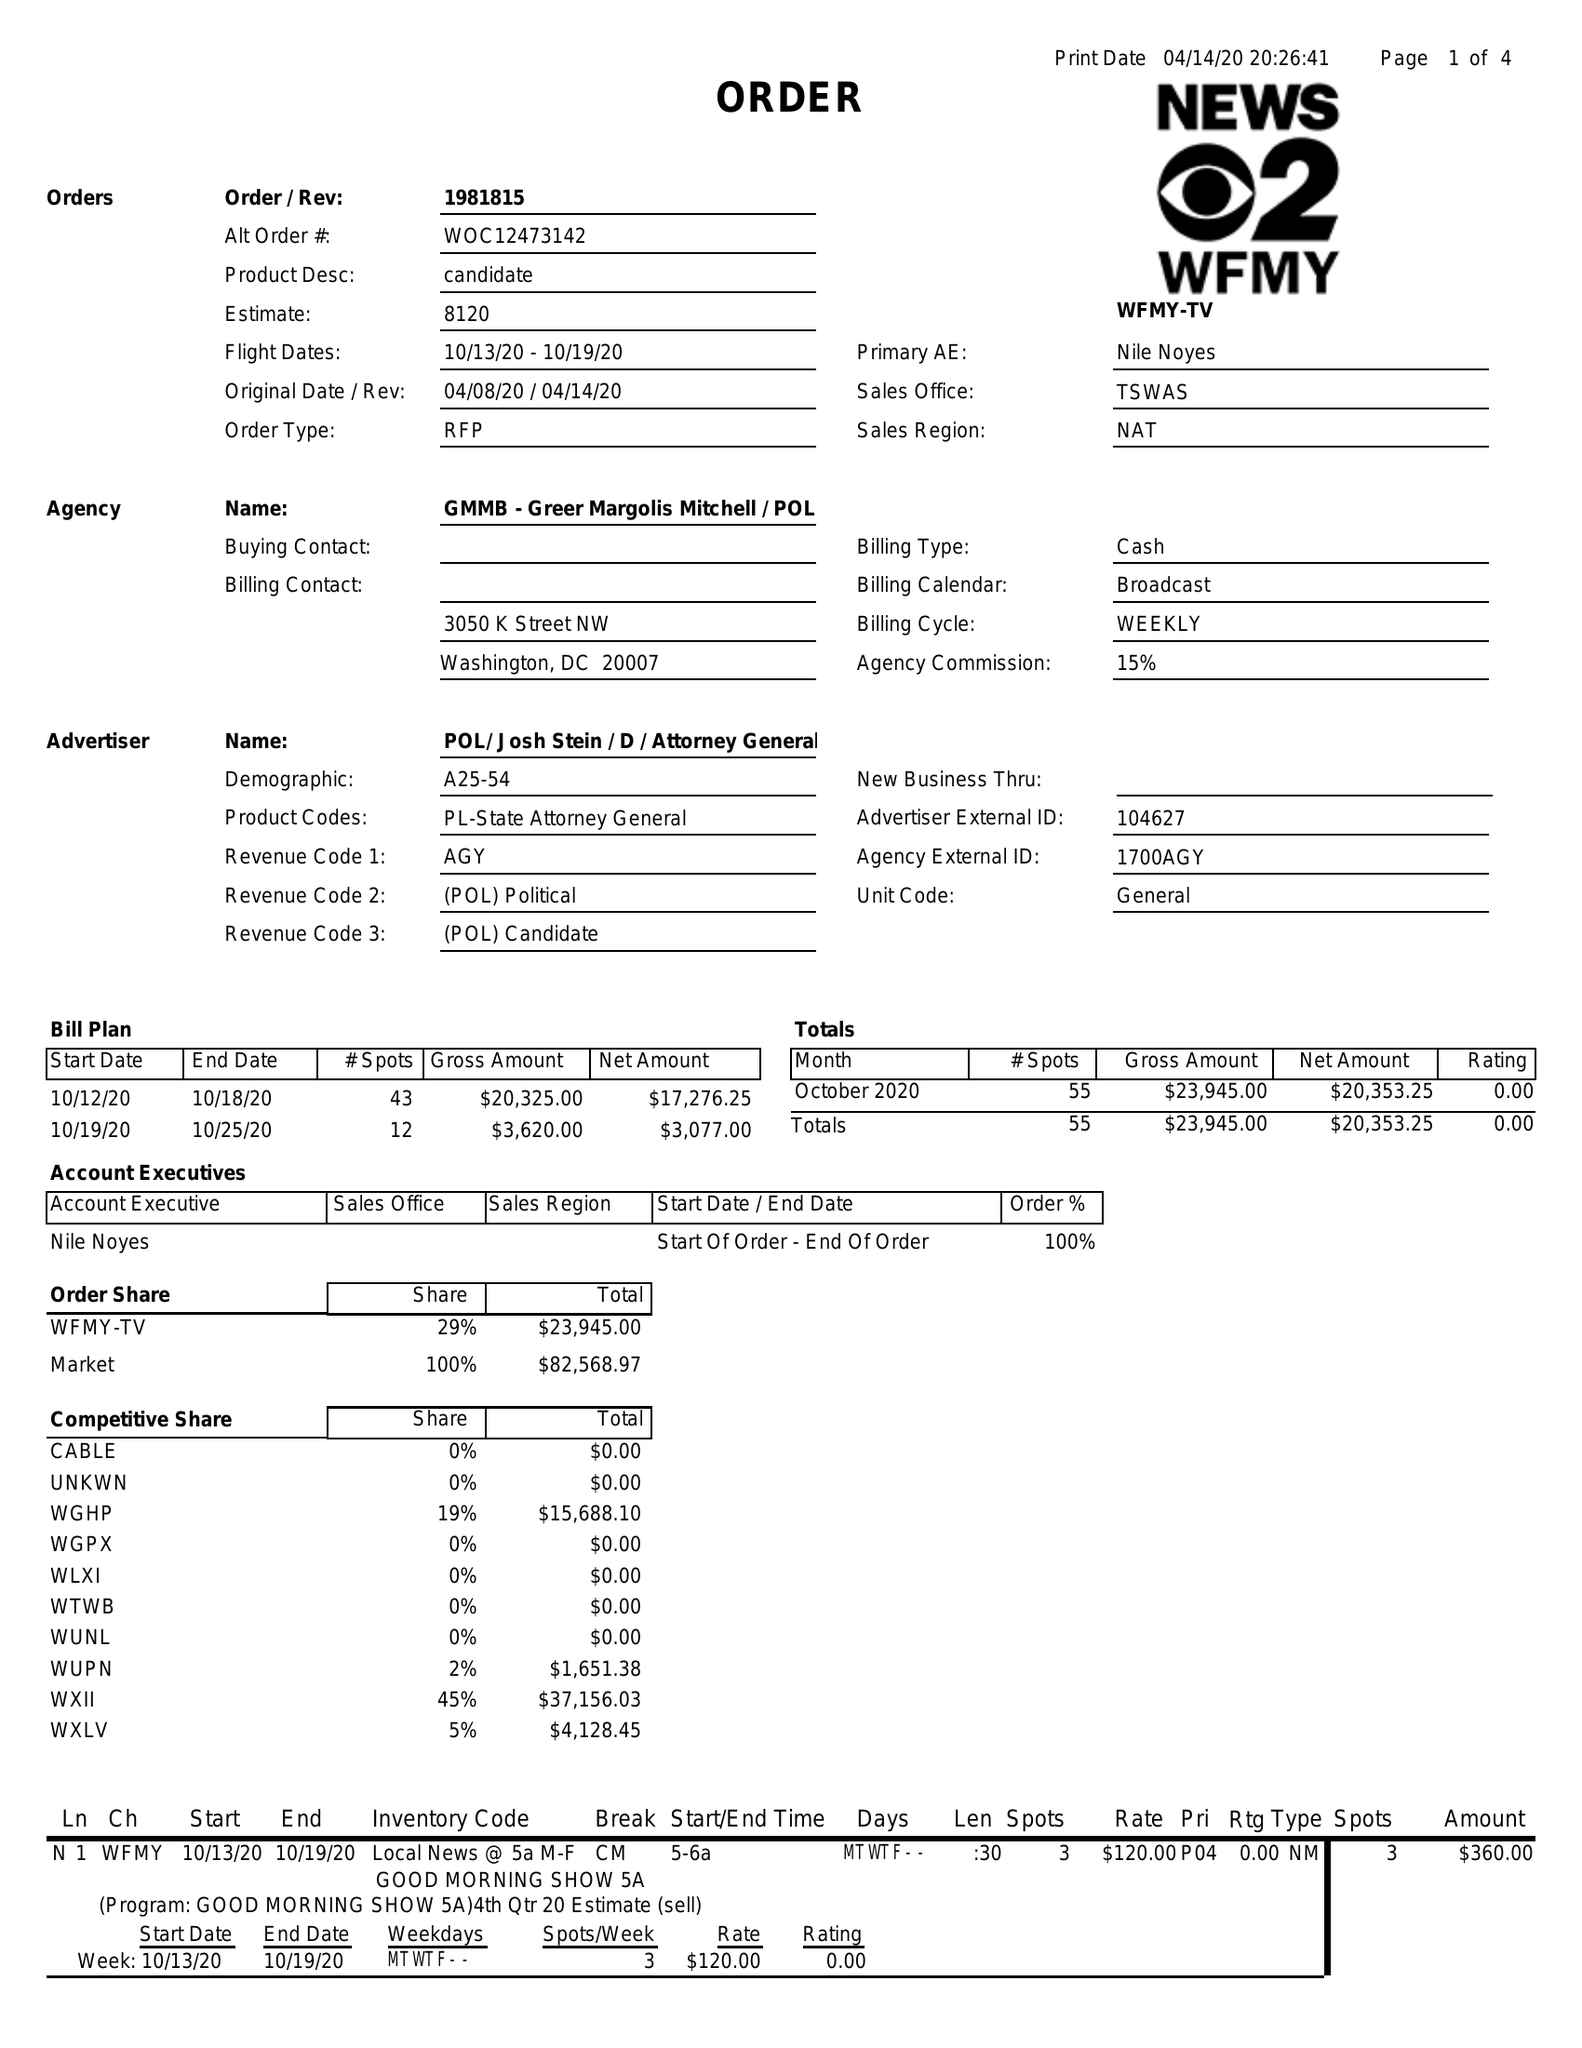What is the value for the contract_num?
Answer the question using a single word or phrase. 1981815 